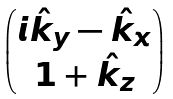Convert formula to latex. <formula><loc_0><loc_0><loc_500><loc_500>\begin{pmatrix} i \hat { k } _ { y } - \hat { k } _ { x } \\ 1 + \hat { k } _ { z } \end{pmatrix}</formula> 